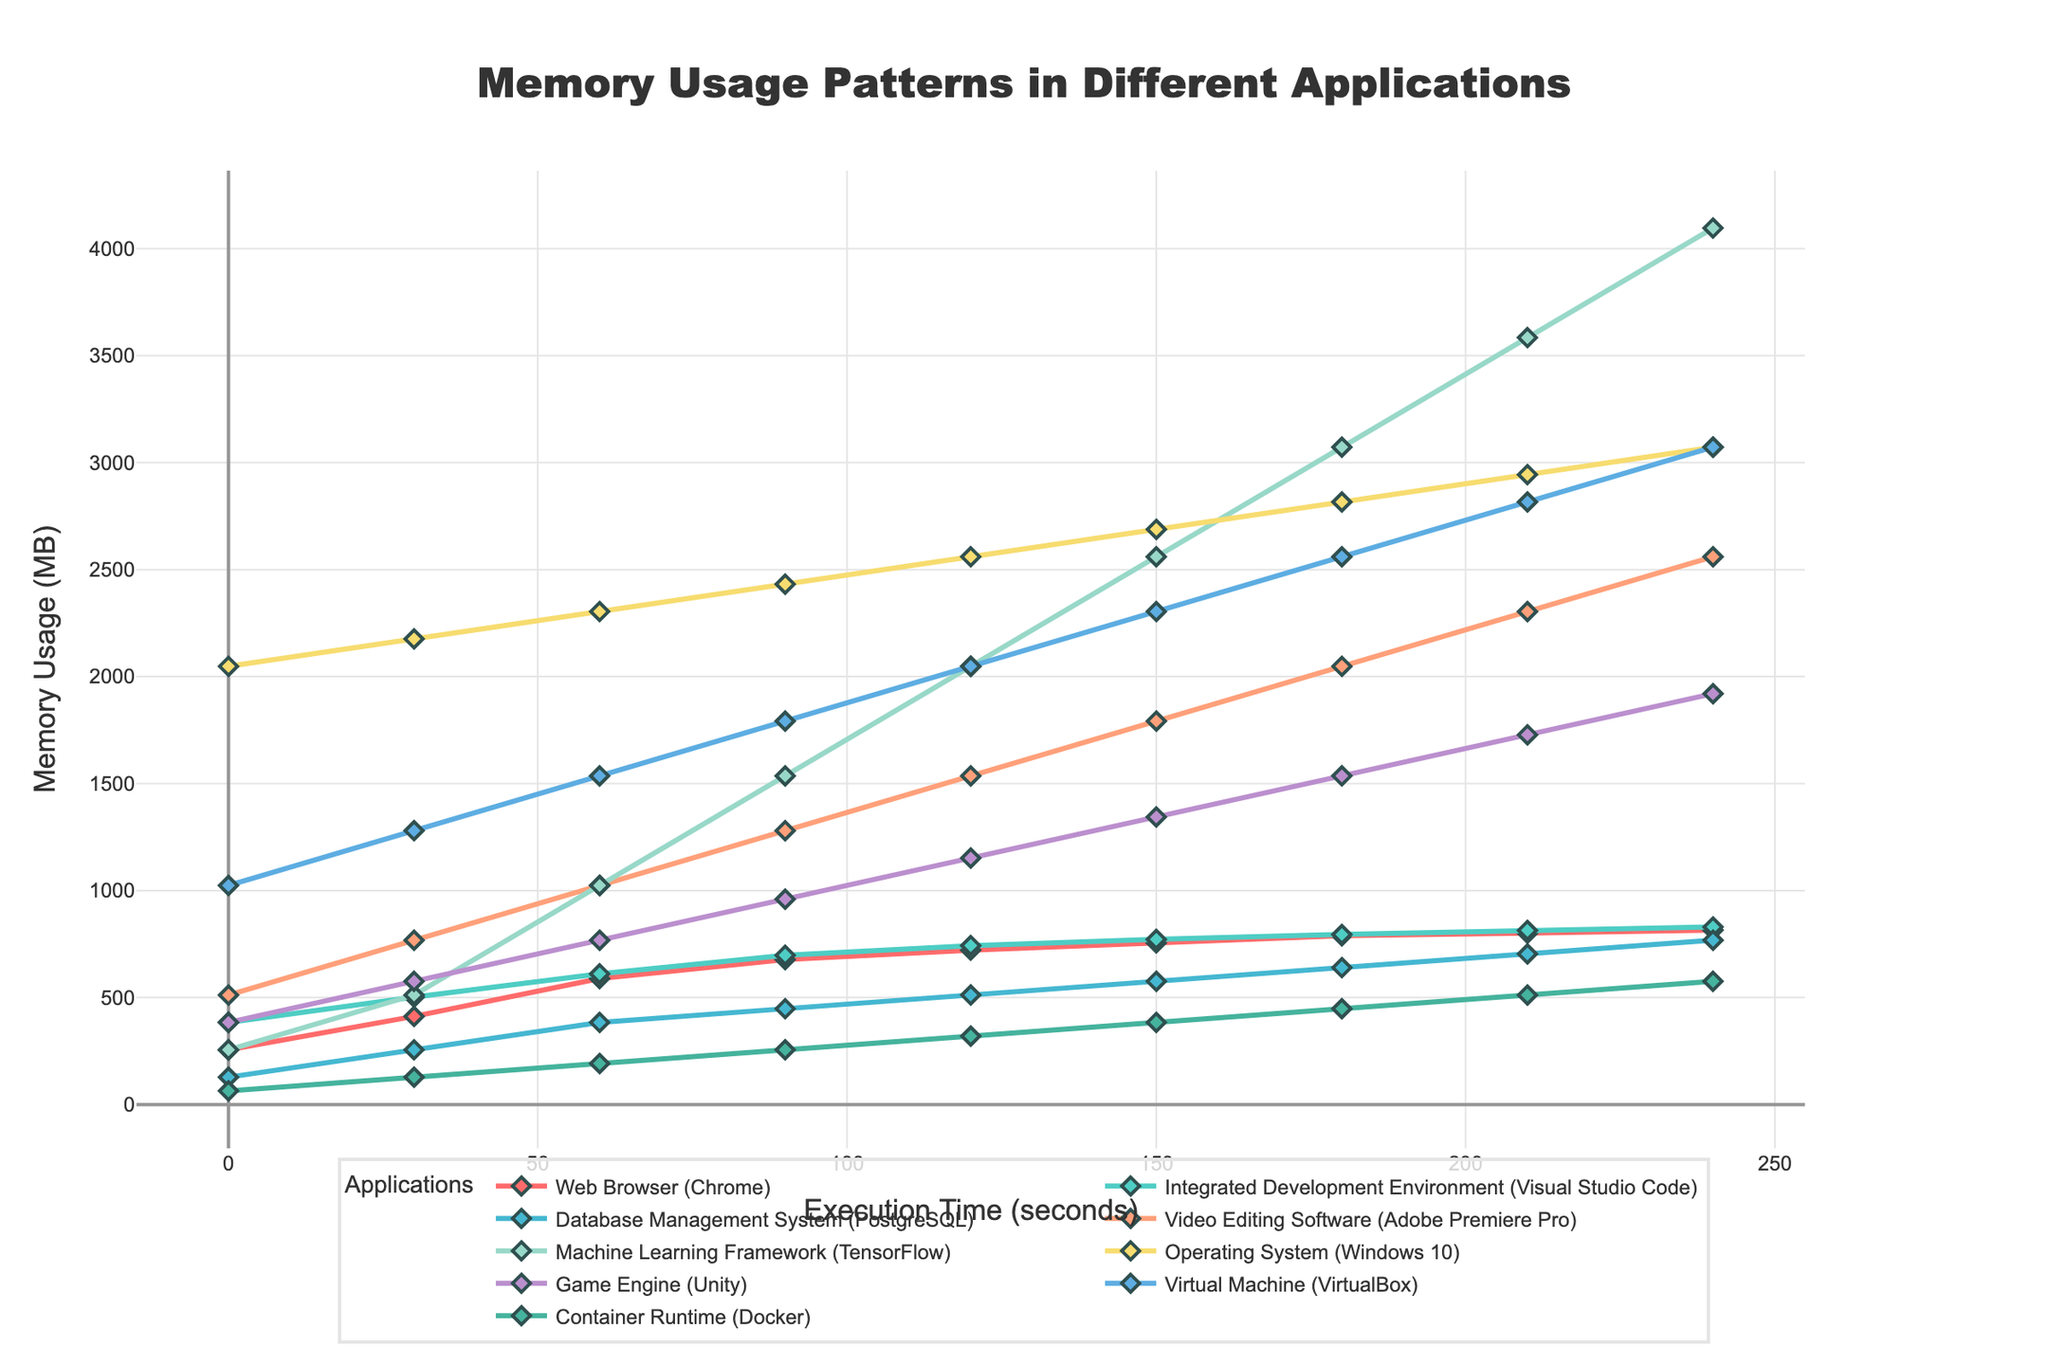What application has the highest memory usage at 240 seconds? At 240 seconds, compare the memory usage for each application. TensorFlow has the highest value at 4096 MB.
Answer: TensorFlow How does the memory usage of Adobe Premiere Pro change over time? Observe the trend for Adobe Premiere Pro from the beginning to the end. The memory usage increases steadily from 512 MB to 2560 MB.
Answer: Steadily increases Which application has the lowest memory usage at the start? Check the memory usage for all applications at 0 seconds. Docker has the lowest value at 64 MB.
Answer: Docker At 120 seconds, how much more memory does TensorFlow use compared to Docker? Compare the memory values for TensorFlow and Docker at 120 seconds (TensorFlow: 2048 MB, Docker: 320 MB), and compute the difference 2048 - 320.
Answer: 1728 MB Between Unity and VirtualBox, which application has a faster growth rate in memory usage by 180 seconds? Compare the memory growth from 0 seconds to 180 seconds for both Unity and VirtualBox. Unity grows from 384 MB to 1536 MB, a growth of 1152 MB, while VirtualBox grows from 1024 MB to 2560 MB, a growth of 1536 MB.
Answer: VirtualBox What is the average memory usage of PostgreSQL at 60, 120, and 180 seconds? Compute the average of the values at 60 seconds (384 MB), 120 seconds (512 MB), and 180 seconds (640 MB): (384 + 512 + 640)/3.
Answer: 512 MB Which application surpassed 1500 MB of memory usage first? Note when each application surpasses 1500 MB in memory usage. TensorFlow passes this mark first at 120 seconds.
Answer: TensorFlow By how much does the memory usage of Chrome increase from 0 to 210 seconds? Calculate the difference between the values at 0 seconds (256 MB) and 210 seconds (801 MB): 801 - 256.
Answer: 545 MB At 150 seconds, how much more memory does Visual Studio Code use compared to PostgreSQL? Compute the difference in memory usage between Visual Studio Code and PostgreSQL at 150 seconds (Visual Studio Code: 772 MB, PostgreSQL: 576 MB).
Answer: 196 MB Describe the general memory usage pattern of Docker. Observe the trend for Docker memory usage, which increases linearly from 64 MB at 0 seconds to 576 MB at 240 seconds.
Answer: Linearly increases 